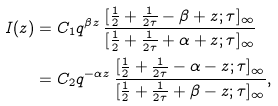<formula> <loc_0><loc_0><loc_500><loc_500>I ( z ) & = C _ { 1 } q ^ { \beta z } \, \frac { [ \frac { 1 } { 2 } + \frac { 1 } { 2 \tau } - \beta + z ; \tau ] _ { \infty } } { [ \frac { 1 } { 2 } + \frac { 1 } { 2 \tau } + \alpha + z ; \tau ] _ { \infty } } \\ & = C _ { 2 } q ^ { - \alpha z } \, \frac { [ \frac { 1 } { 2 } + \frac { 1 } { 2 \tau } - \alpha - z ; \tau ] _ { \infty } } { [ \frac { 1 } { 2 } + \frac { 1 } { 2 \tau } + \beta - z ; \tau ] _ { \infty } } ,</formula> 